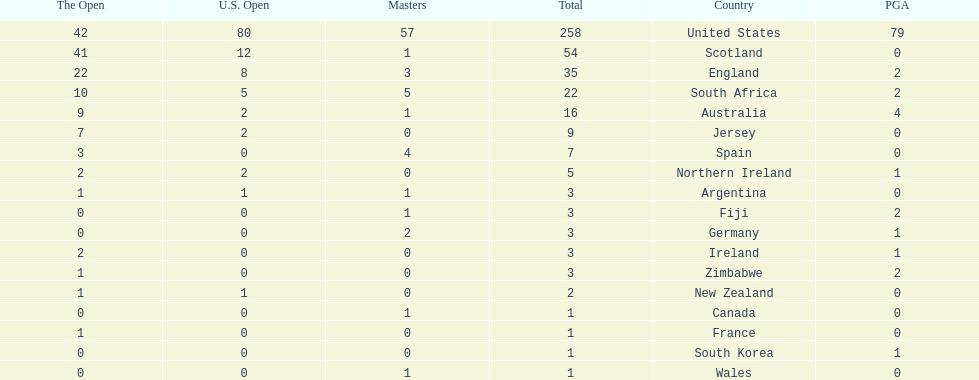Which african country has the least champion golfers according to this table? Zimbabwe. 